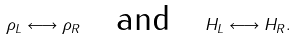Convert formula to latex. <formula><loc_0><loc_0><loc_500><loc_500>\rho _ { L } \longleftrightarrow \rho _ { R } \quad \text {and} \quad H _ { L } \longleftrightarrow H _ { R } .</formula> 